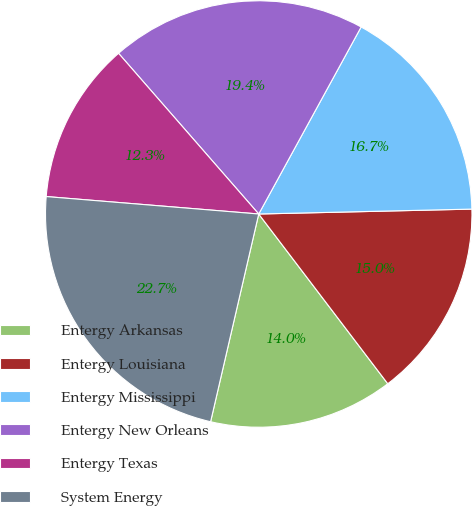Convert chart. <chart><loc_0><loc_0><loc_500><loc_500><pie_chart><fcel>Entergy Arkansas<fcel>Entergy Louisiana<fcel>Entergy Mississippi<fcel>Entergy New Orleans<fcel>Entergy Texas<fcel>System Energy<nl><fcel>13.97%<fcel>15.02%<fcel>16.66%<fcel>19.39%<fcel>12.28%<fcel>22.68%<nl></chart> 